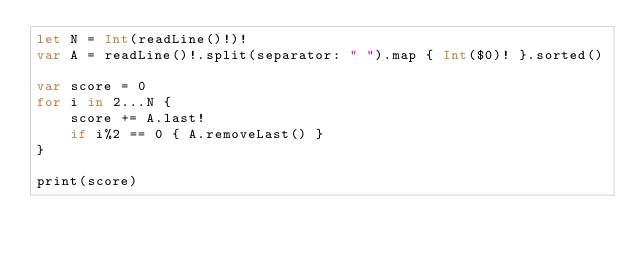<code> <loc_0><loc_0><loc_500><loc_500><_Swift_>let N = Int(readLine()!)!
var A = readLine()!.split(separator: " ").map { Int($0)! }.sorted()

var score = 0
for i in 2...N {
	score += A.last!
	if i%2 == 0 { A.removeLast() }
}

print(score)
</code> 